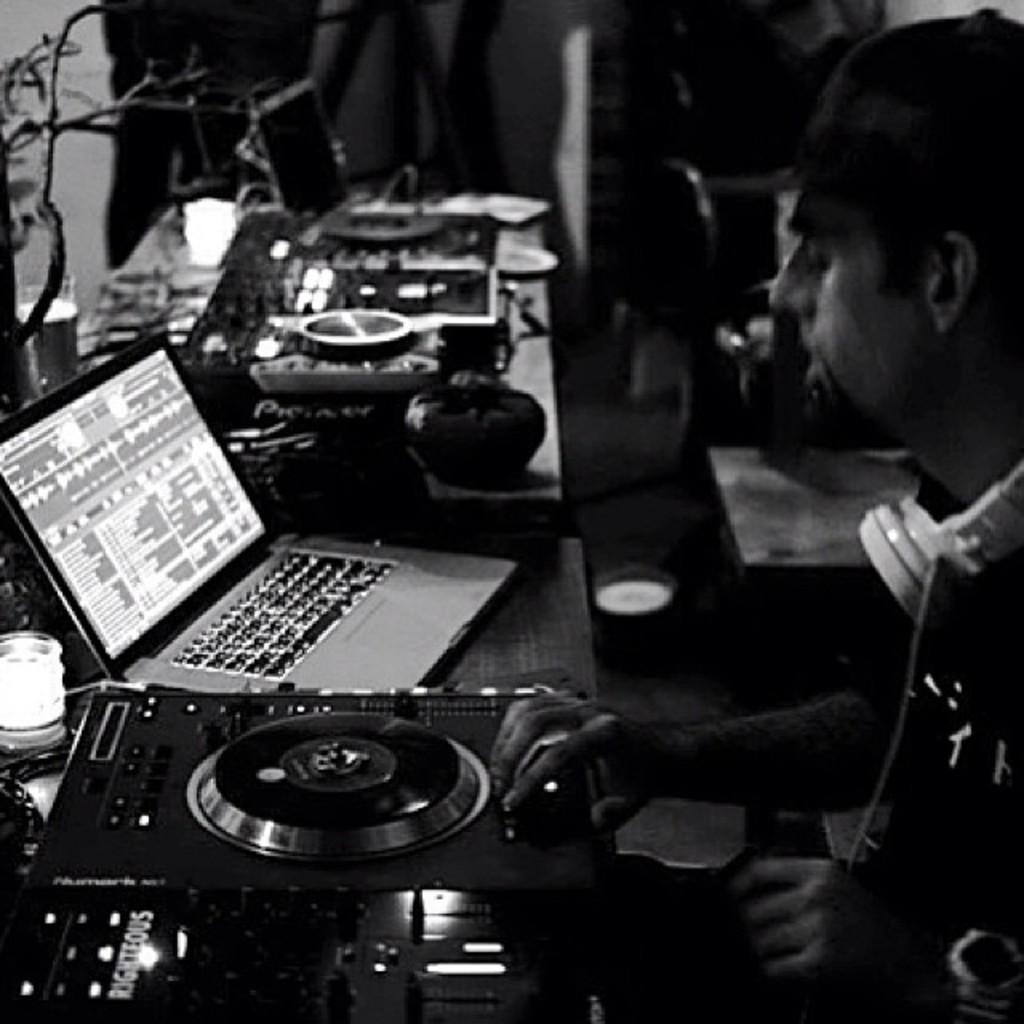Where is the person located in the image? The person is sitting in the right corner of the image. What is in front of the person? There is an amplifier in front of the person. What device is placed beside the amplifier? There is a laptop beside the amplifier. What other objects can be seen on the table beside the laptop? There are other objects placed on the table beside the laptop. Where is the faucet located in the image? There is no faucet present in the image. How many children are visible in the image? There are no children visible in the image. Is there a cactus in the image? There is no cactus present in the image. 